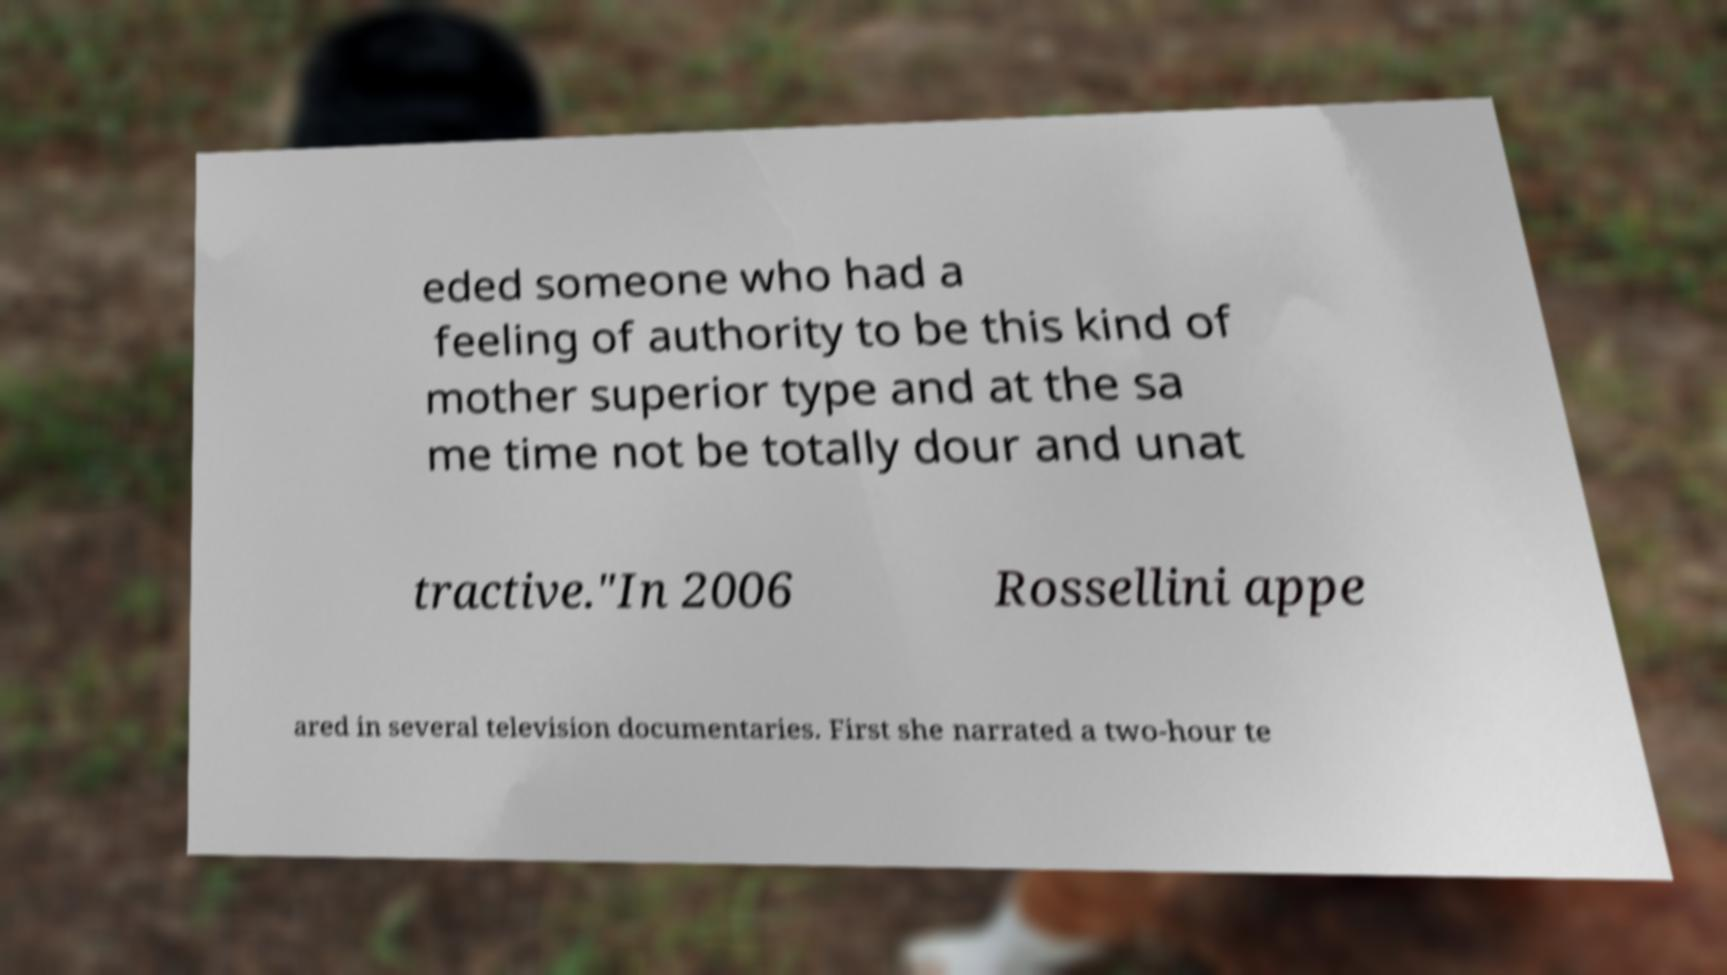I need the written content from this picture converted into text. Can you do that? eded someone who had a feeling of authority to be this kind of mother superior type and at the sa me time not be totally dour and unat tractive."In 2006 Rossellini appe ared in several television documentaries. First she narrated a two-hour te 